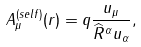Convert formula to latex. <formula><loc_0><loc_0><loc_500><loc_500>A _ { \mu } ^ { ( s e l f ) } ( r ) = q \frac { u _ { \mu } } { \widehat { R } ^ { \alpha } u _ { \alpha } } ,</formula> 